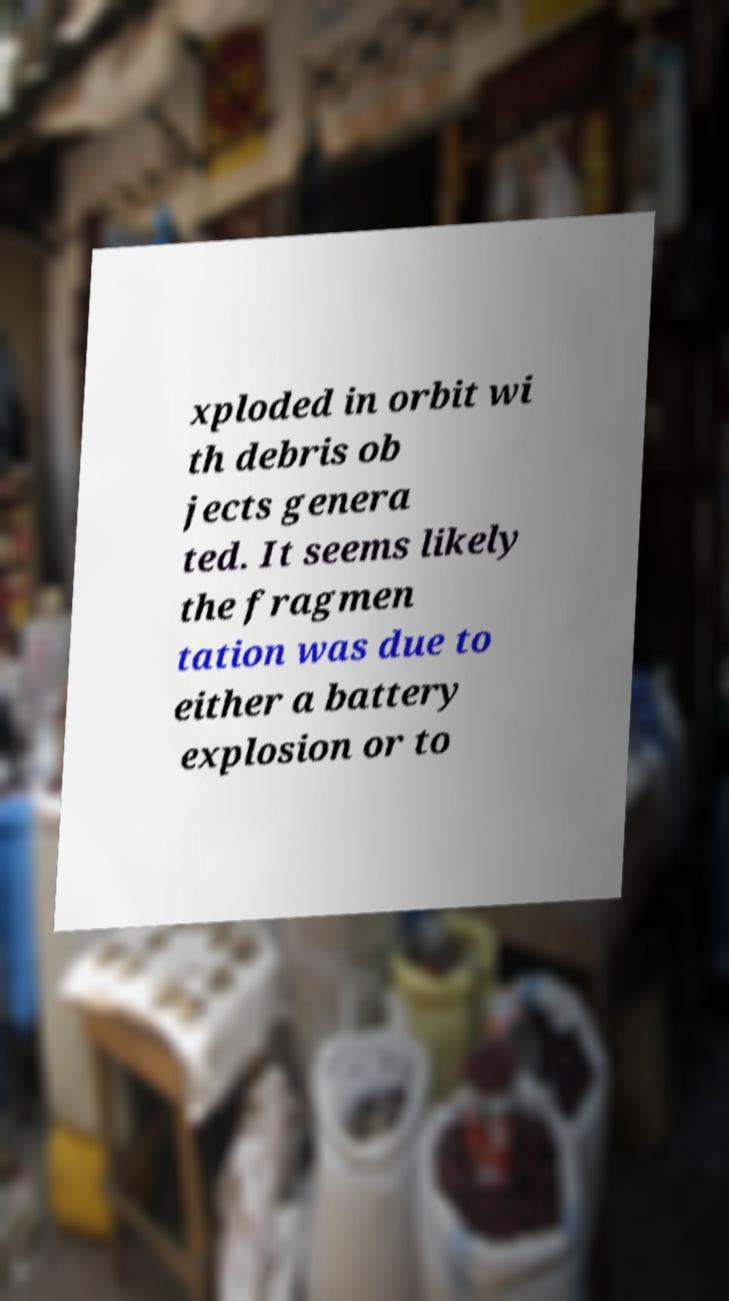Can you read and provide the text displayed in the image?This photo seems to have some interesting text. Can you extract and type it out for me? xploded in orbit wi th debris ob jects genera ted. It seems likely the fragmen tation was due to either a battery explosion or to 